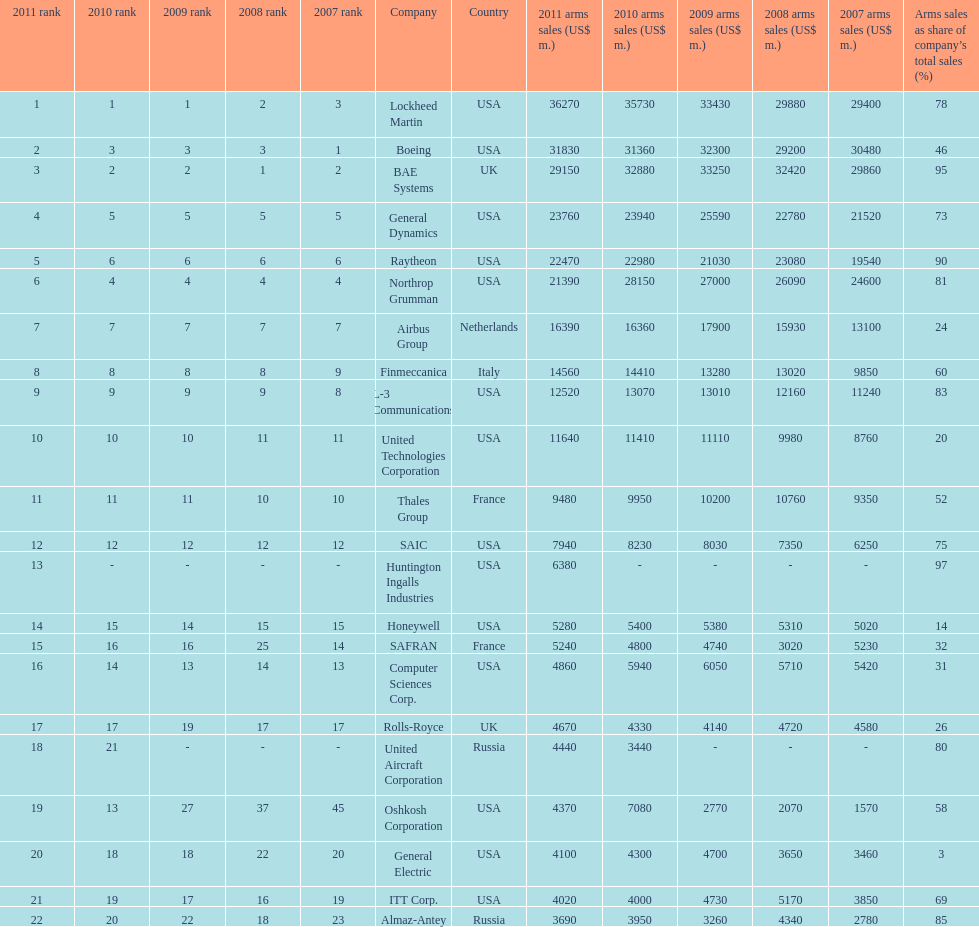Which is the only company to have under 10% arms sales as share of company's total sales? General Electric. 